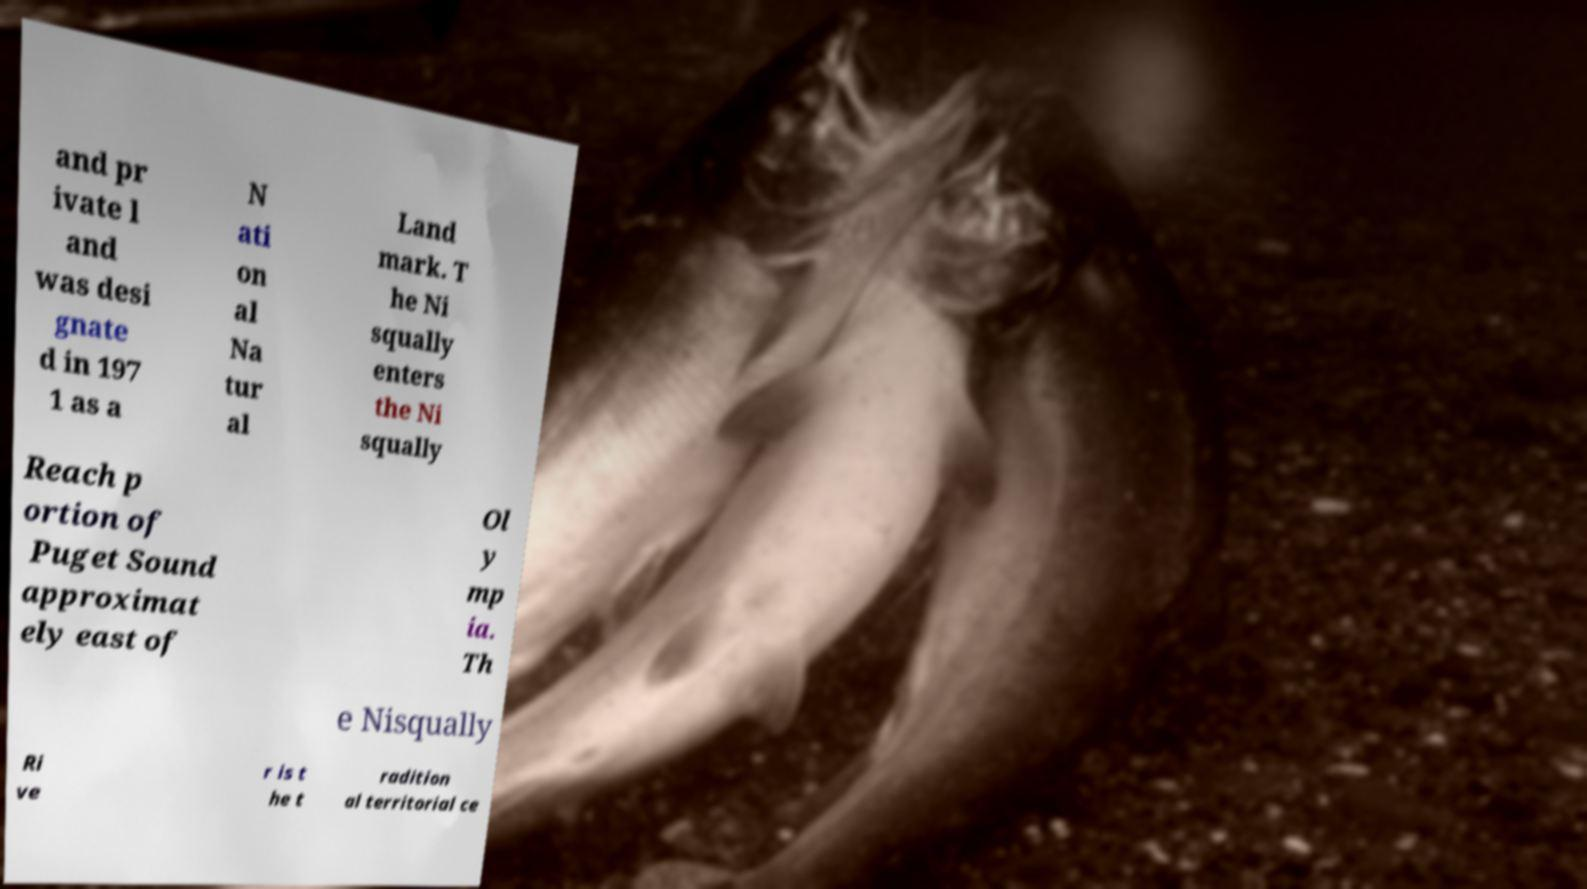Could you extract and type out the text from this image? and pr ivate l and was desi gnate d in 197 1 as a N ati on al Na tur al Land mark. T he Ni squally enters the Ni squally Reach p ortion of Puget Sound approximat ely east of Ol y mp ia. Th e Nisqually Ri ve r is t he t radition al territorial ce 